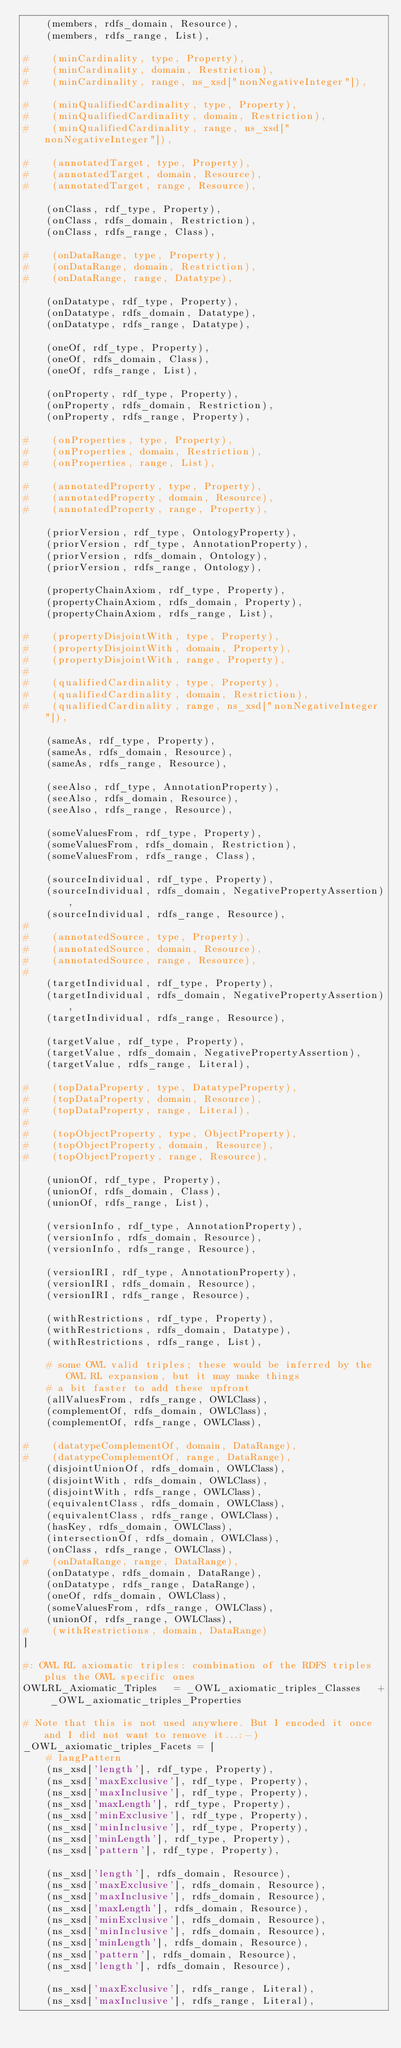Convert code to text. <code><loc_0><loc_0><loc_500><loc_500><_Python_>    (members, rdfs_domain, Resource),
    (members, rdfs_range, List),

#    (minCardinality, type, Property),
#    (minCardinality, domain, Restriction),
#    (minCardinality, range, ns_xsd["nonNegativeInteger"]),

#    (minQualifiedCardinality, type, Property),
#    (minQualifiedCardinality, domain, Restriction),
#    (minQualifiedCardinality, range, ns_xsd["nonNegativeInteger"]),

#    (annotatedTarget, type, Property),
#    (annotatedTarget, domain, Resource),
#    (annotatedTarget, range, Resource),

    (onClass, rdf_type, Property),
    (onClass, rdfs_domain, Restriction),
    (onClass, rdfs_range, Class),

#    (onDataRange, type, Property),
#    (onDataRange, domain, Restriction),
#    (onDataRange, range, Datatype),

    (onDatatype, rdf_type, Property),
    (onDatatype, rdfs_domain, Datatype),
    (onDatatype, rdfs_range, Datatype),

    (oneOf, rdf_type, Property),
    (oneOf, rdfs_domain, Class),
    (oneOf, rdfs_range, List),

    (onProperty, rdf_type, Property),
    (onProperty, rdfs_domain, Restriction),
    (onProperty, rdfs_range, Property),

#    (onProperties, type, Property),
#    (onProperties, domain, Restriction),
#    (onProperties, range, List),

#    (annotatedProperty, type, Property),
#    (annotatedProperty, domain, Resource),
#    (annotatedProperty, range, Property),

    (priorVersion, rdf_type, OntologyProperty),
    (priorVersion, rdf_type, AnnotationProperty),
    (priorVersion, rdfs_domain, Ontology),
    (priorVersion, rdfs_range, Ontology),

    (propertyChainAxiom, rdf_type, Property),
    (propertyChainAxiom, rdfs_domain, Property),
    (propertyChainAxiom, rdfs_range, List),

#    (propertyDisjointWith, type, Property),
#    (propertyDisjointWith, domain, Property),
#    (propertyDisjointWith, range, Property),
#
#    (qualifiedCardinality, type, Property),
#    (qualifiedCardinality, domain, Restriction),
#    (qualifiedCardinality, range, ns_xsd["nonNegativeInteger"]),

    (sameAs, rdf_type, Property),
    (sameAs, rdfs_domain, Resource),
    (sameAs, rdfs_range, Resource),

    (seeAlso, rdf_type, AnnotationProperty),
    (seeAlso, rdfs_domain, Resource),
    (seeAlso, rdfs_range, Resource),

    (someValuesFrom, rdf_type, Property),
    (someValuesFrom, rdfs_domain, Restriction),
    (someValuesFrom, rdfs_range, Class),

    (sourceIndividual, rdf_type, Property),
    (sourceIndividual, rdfs_domain, NegativePropertyAssertion),
    (sourceIndividual, rdfs_range, Resource),
#
#    (annotatedSource, type, Property),
#    (annotatedSource, domain, Resource),
#    (annotatedSource, range, Resource),
#
    (targetIndividual, rdf_type, Property),
    (targetIndividual, rdfs_domain, NegativePropertyAssertion),
    (targetIndividual, rdfs_range, Resource),

    (targetValue, rdf_type, Property),
    (targetValue, rdfs_domain, NegativePropertyAssertion),
    (targetValue, rdfs_range, Literal),

#    (topDataProperty, type, DatatypeProperty),
#    (topDataProperty, domain, Resource),
#    (topDataProperty, range, Literal),
#
#    (topObjectProperty, type, ObjectProperty),
#    (topObjectProperty, domain, Resource),
#    (topObjectProperty, range, Resource),

    (unionOf, rdf_type, Property),
    (unionOf, rdfs_domain, Class),
    (unionOf, rdfs_range, List),

    (versionInfo, rdf_type, AnnotationProperty),
    (versionInfo, rdfs_domain, Resource),
    (versionInfo, rdfs_range, Resource),

    (versionIRI, rdf_type, AnnotationProperty),
    (versionIRI, rdfs_domain, Resource),
    (versionIRI, rdfs_range, Resource),

    (withRestrictions, rdf_type, Property),
    (withRestrictions, rdfs_domain, Datatype),
    (withRestrictions, rdfs_range, List),

    # some OWL valid triples; these would be inferred by the OWL RL expansion, but it may make things
    # a bit faster to add these upfront
    (allValuesFrom, rdfs_range, OWLClass),
    (complementOf, rdfs_domain, OWLClass),
    (complementOf, rdfs_range, OWLClass),

#    (datatypeComplementOf, domain, DataRange),
#    (datatypeComplementOf, range, DataRange),
    (disjointUnionOf, rdfs_domain, OWLClass),
    (disjointWith, rdfs_domain, OWLClass),
    (disjointWith, rdfs_range, OWLClass),
    (equivalentClass, rdfs_domain, OWLClass),
    (equivalentClass, rdfs_range, OWLClass),
    (hasKey, rdfs_domain, OWLClass),
    (intersectionOf, rdfs_domain, OWLClass),
    (onClass, rdfs_range, OWLClass),
#    (onDataRange, range, DataRange),
    (onDatatype, rdfs_domain, DataRange),
    (onDatatype, rdfs_range, DataRange),
    (oneOf, rdfs_domain, OWLClass),
    (someValuesFrom, rdfs_range, OWLClass),
    (unionOf, rdfs_range, OWLClass),
#    (withRestrictions, domain, DataRange)
]

#: OWL RL axiomatic triples: combination of the RDFS triples plus the OWL specific ones
OWLRL_Axiomatic_Triples   = _OWL_axiomatic_triples_Classes   + _OWL_axiomatic_triples_Properties

# Note that this is not used anywhere. But I encoded it once and I did not want to remove it...:-)
_OWL_axiomatic_triples_Facets = [
    # langPattern
    (ns_xsd['length'], rdf_type, Property),
    (ns_xsd['maxExclusive'], rdf_type, Property),
    (ns_xsd['maxInclusive'], rdf_type, Property),
    (ns_xsd['maxLength'], rdf_type, Property),
    (ns_xsd['minExclusive'], rdf_type, Property),
    (ns_xsd['minInclusive'], rdf_type, Property),
    (ns_xsd['minLength'], rdf_type, Property),
    (ns_xsd['pattern'], rdf_type, Property),

    (ns_xsd['length'], rdfs_domain, Resource),
    (ns_xsd['maxExclusive'], rdfs_domain, Resource),
    (ns_xsd['maxInclusive'], rdfs_domain, Resource),
    (ns_xsd['maxLength'], rdfs_domain, Resource),
    (ns_xsd['minExclusive'], rdfs_domain, Resource),
    (ns_xsd['minInclusive'], rdfs_domain, Resource),
    (ns_xsd['minLength'], rdfs_domain, Resource),
    (ns_xsd['pattern'], rdfs_domain, Resource),
    (ns_xsd['length'], rdfs_domain, Resource),

    (ns_xsd['maxExclusive'], rdfs_range, Literal),
    (ns_xsd['maxInclusive'], rdfs_range, Literal),</code> 